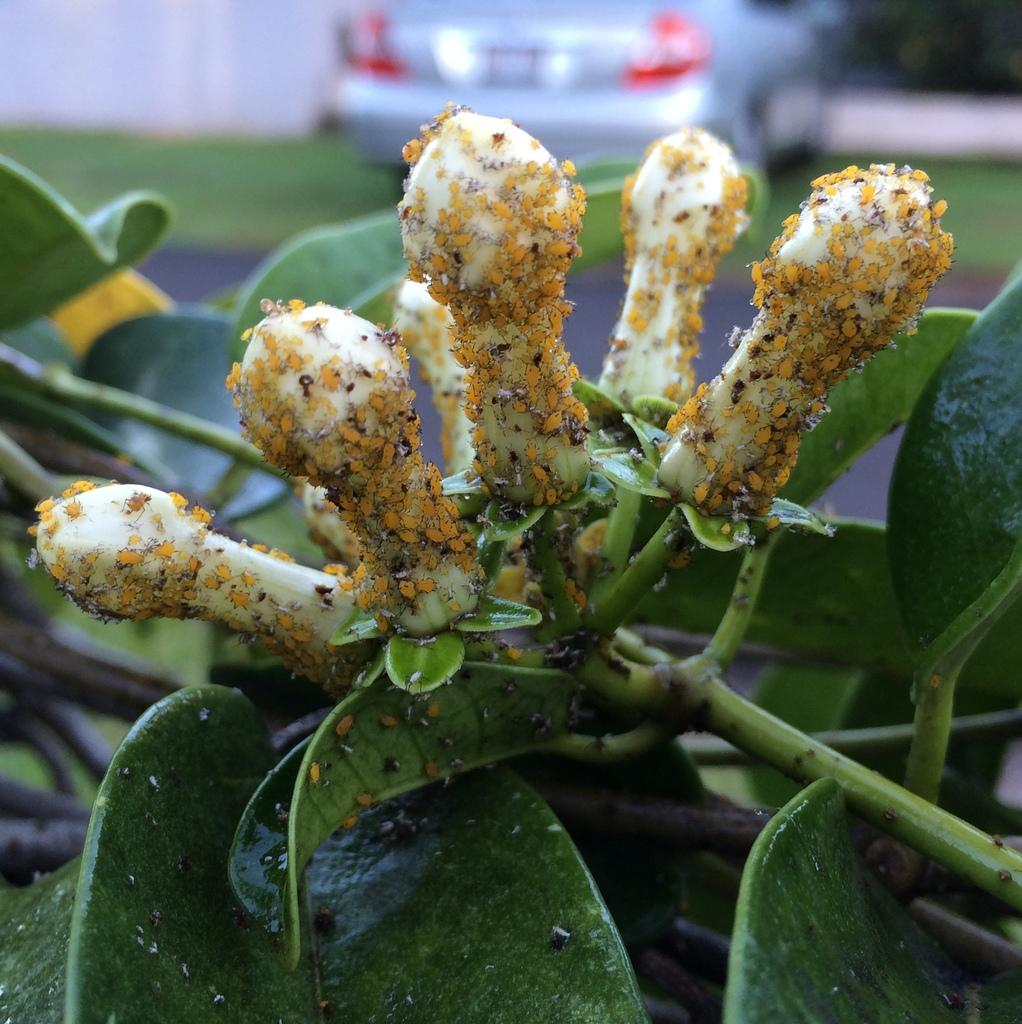What color are the leaves in the image? The leaves in the image are green. What other color can be seen in the image besides green? There are white color things in the image. What can be seen in the background of the image? There is a car visible in the background of the image. How would you describe the clarity of the image in the background? The image is slightly blurry in the background. What type of attraction is present in the image? There is no attraction present in the image; it primarily features leaves, white things, and a car in the background. What is the profit margin of the base in the image? There is no base or profit margin mentioned in the image; it is a photograph of leaves, white things, and a car in the background. 